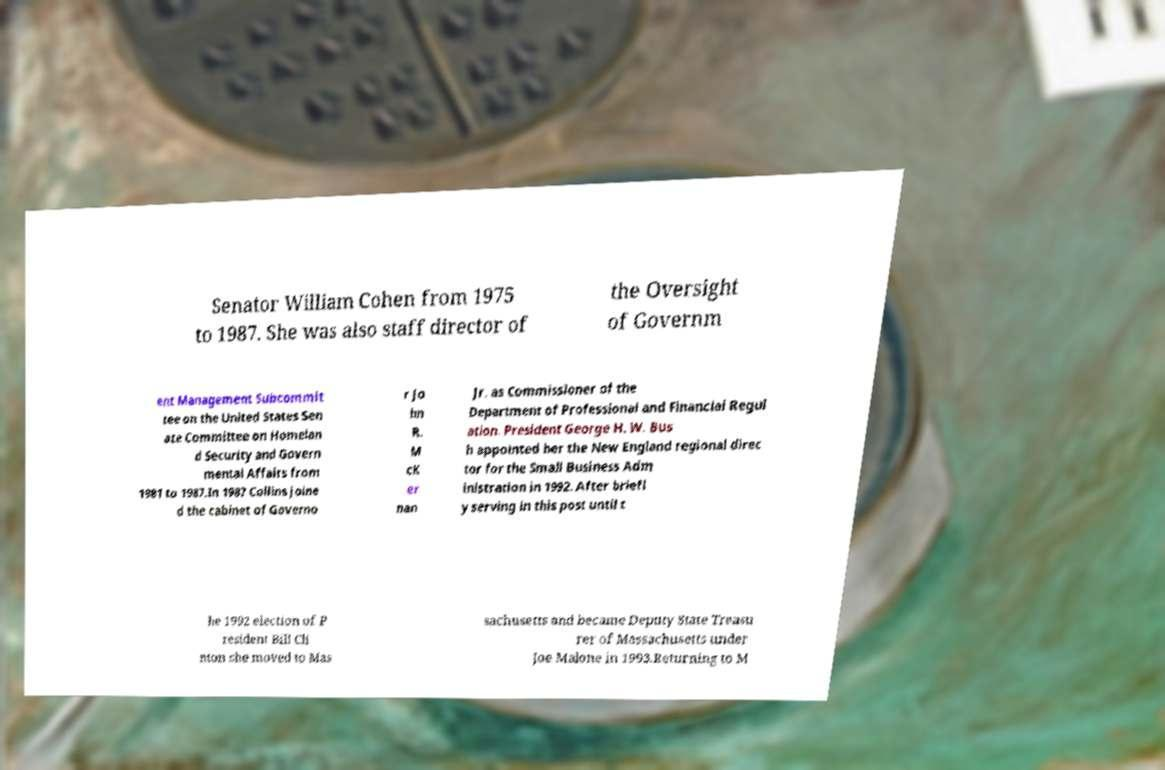Could you assist in decoding the text presented in this image and type it out clearly? Senator William Cohen from 1975 to 1987. She was also staff director of the Oversight of Governm ent Management Subcommit tee on the United States Sen ate Committee on Homelan d Security and Govern mental Affairs from 1981 to 1987.In 1987 Collins joine d the cabinet of Governo r Jo hn R. M cK er nan Jr. as Commissioner of the Department of Professional and Financial Regul ation. President George H. W. Bus h appointed her the New England regional direc tor for the Small Business Adm inistration in 1992. After briefl y serving in this post until t he 1992 election of P resident Bill Cli nton she moved to Mas sachusetts and became Deputy State Treasu rer of Massachusetts under Joe Malone in 1993.Returning to M 